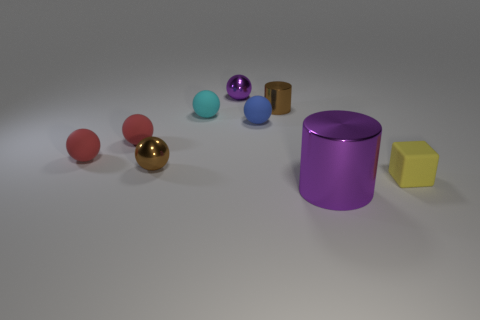Are there more tiny metallic cylinders to the left of the cyan matte sphere than purple objects that are on the right side of the large purple shiny cylinder?
Give a very brief answer. No. The other purple thing that is the same material as the large thing is what shape?
Your answer should be compact. Sphere. What number of other things are the same shape as the big shiny object?
Provide a succinct answer. 1. What shape is the small brown metallic object that is to the left of the purple ball?
Provide a short and direct response. Sphere. What is the color of the small block?
Make the answer very short. Yellow. What number of other objects are there of the same size as the brown shiny sphere?
Provide a succinct answer. 7. There is a purple thing that is behind the brown cylinder that is on the left side of the small yellow block; what is its material?
Keep it short and to the point. Metal. Is the size of the purple cylinder the same as the brown object that is to the right of the blue sphere?
Make the answer very short. No. Is there another metallic object of the same color as the big metal object?
Offer a terse response. Yes. How many tiny things are metallic objects or yellow matte objects?
Offer a terse response. 4. 